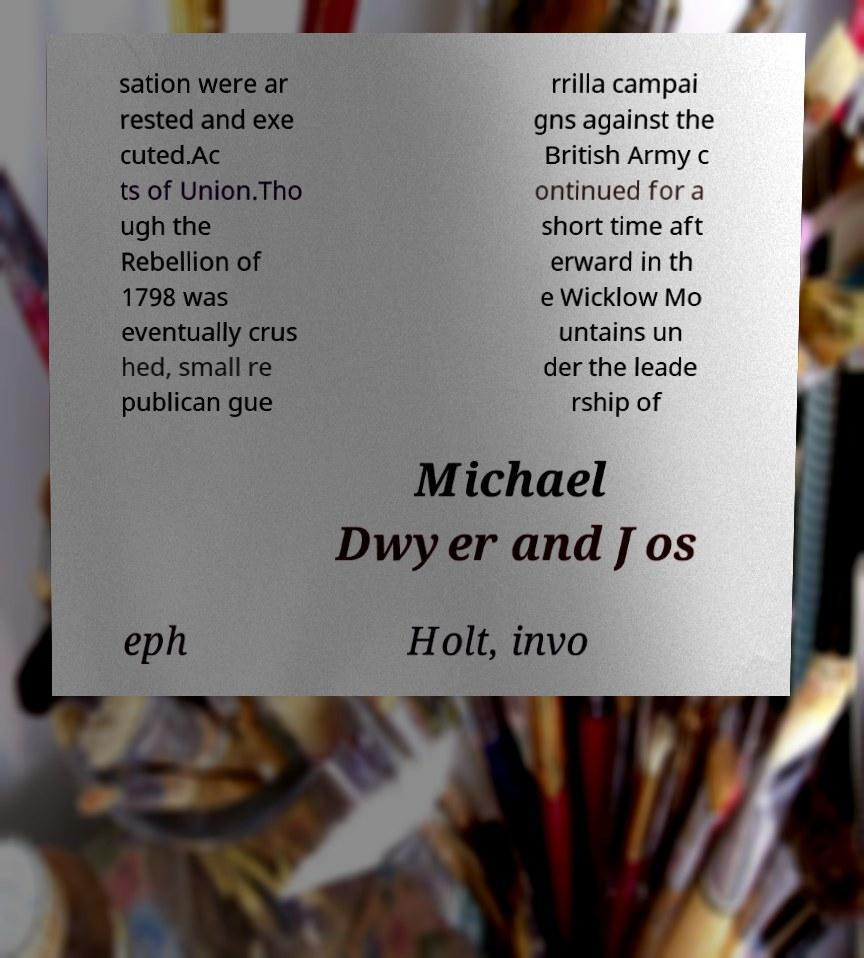What messages or text are displayed in this image? I need them in a readable, typed format. sation were ar rested and exe cuted.Ac ts of Union.Tho ugh the Rebellion of 1798 was eventually crus hed, small re publican gue rrilla campai gns against the British Army c ontinued for a short time aft erward in th e Wicklow Mo untains un der the leade rship of Michael Dwyer and Jos eph Holt, invo 